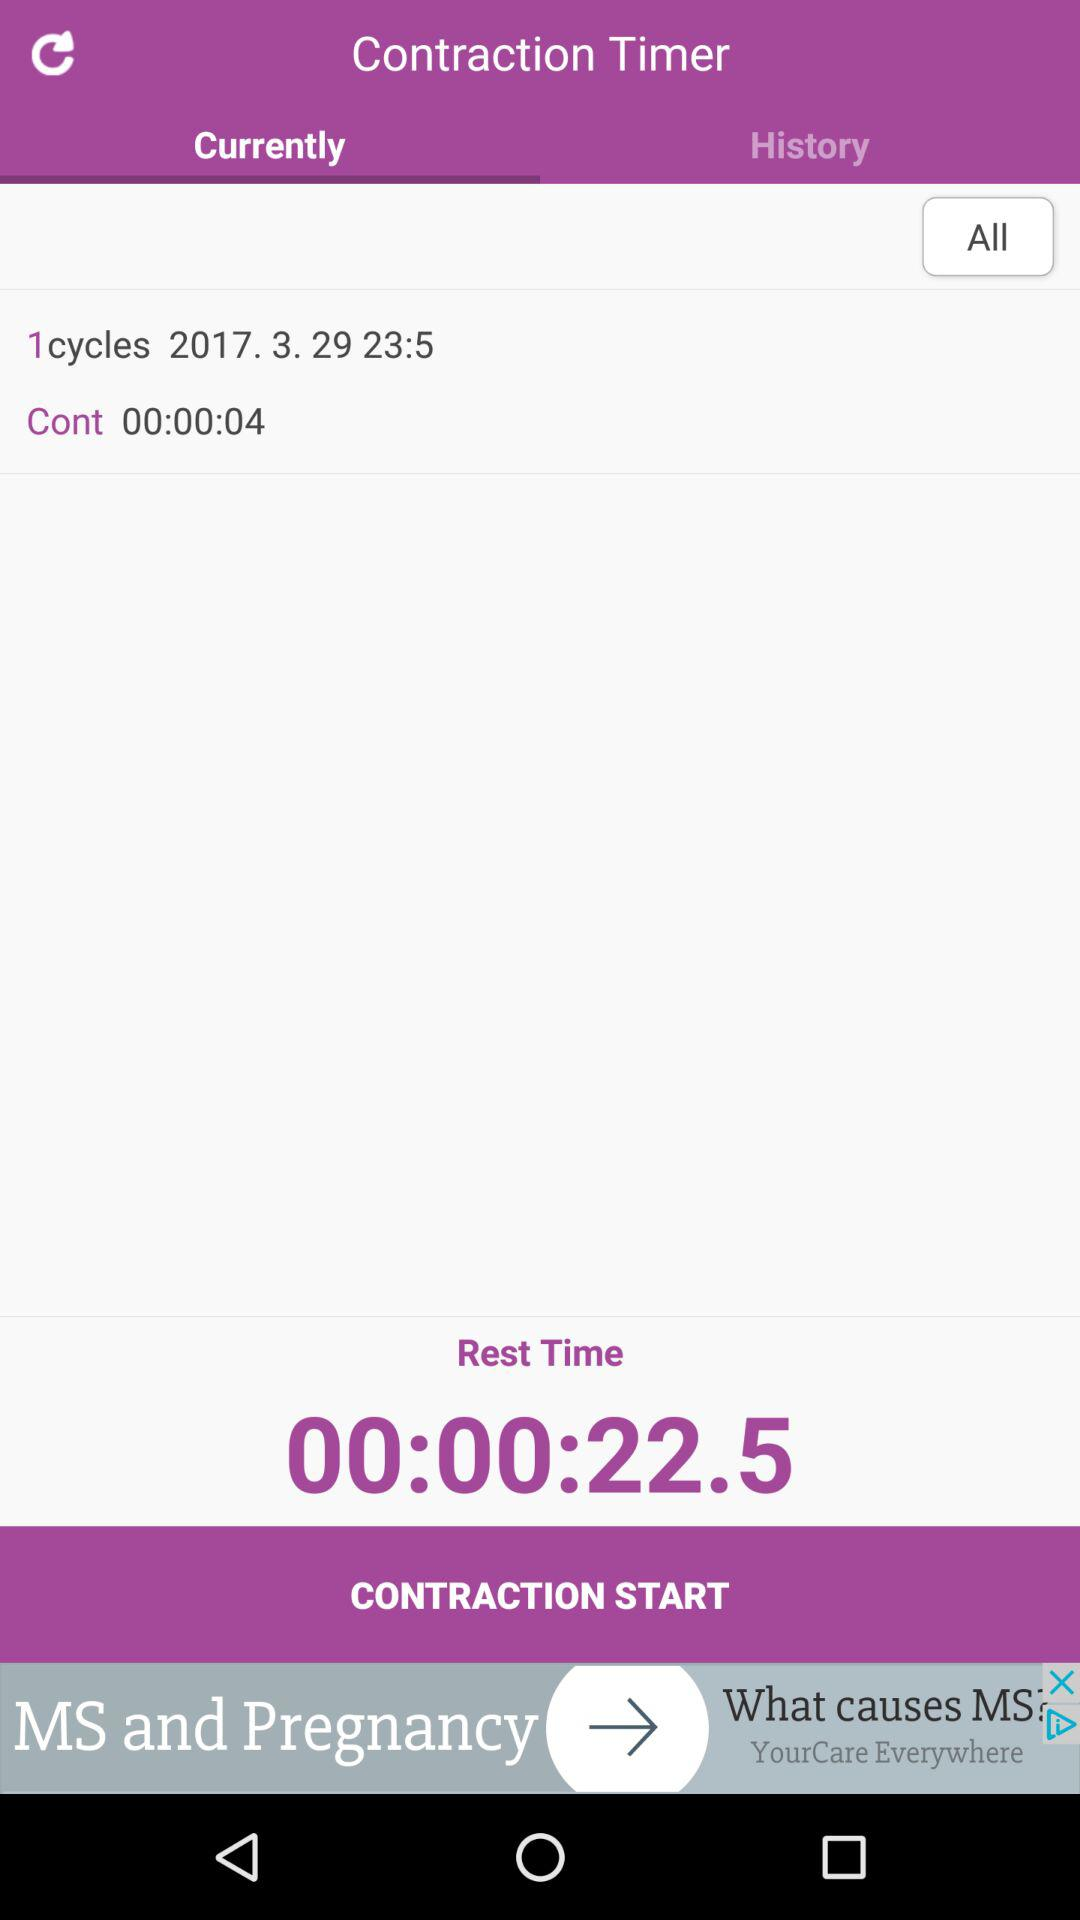On what date was "1cycles" completed? The date is March 29, 2017. 